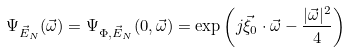Convert formula to latex. <formula><loc_0><loc_0><loc_500><loc_500>\Psi _ { \vec { E } _ { N } } ( \vec { \omega } ) = \Psi _ { \Phi , \vec { E } _ { N } } ( 0 , \vec { \omega } ) = \exp \left ( j \vec { \xi } _ { 0 } \cdot \vec { \omega } - \frac { | \vec { \omega } | ^ { 2 } } { 4 } \right )</formula> 